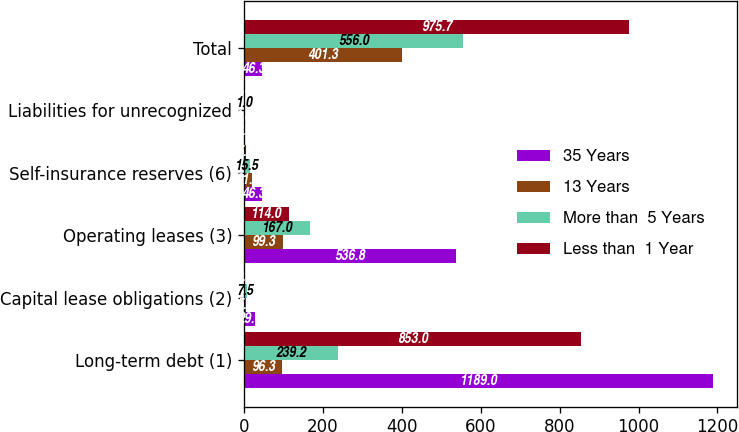Convert chart to OTSL. <chart><loc_0><loc_0><loc_500><loc_500><stacked_bar_chart><ecel><fcel>Long-term debt (1)<fcel>Capital lease obligations (2)<fcel>Operating leases (3)<fcel>Self-insurance reserves (6)<fcel>Liabilities for unrecognized<fcel>Total<nl><fcel>35 Years<fcel>1189<fcel>29.1<fcel>536.8<fcel>46.3<fcel>2.3<fcel>46.3<nl><fcel>13 Years<fcel>96.3<fcel>5.5<fcel>99.3<fcel>21.7<fcel>0.4<fcel>401.3<nl><fcel>More than  5 Years<fcel>239.2<fcel>7.5<fcel>167<fcel>15.5<fcel>1<fcel>556<nl><fcel>Less than  1 Year<fcel>853<fcel>2.3<fcel>114<fcel>5.8<fcel>0.5<fcel>975.7<nl></chart> 